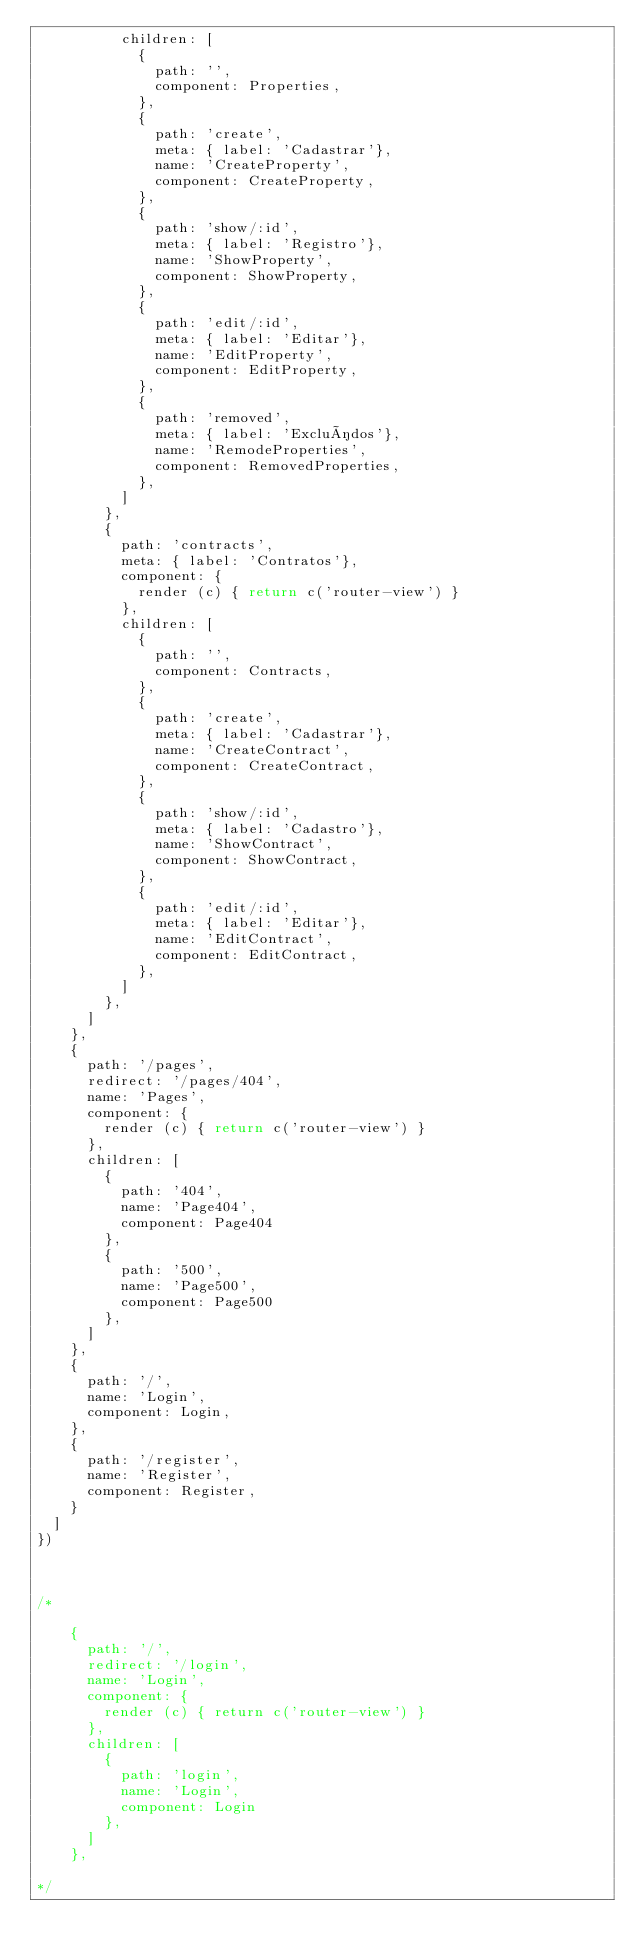Convert code to text. <code><loc_0><loc_0><loc_500><loc_500><_JavaScript_>          children: [
            {
              path: '',
              component: Properties,
            },
            {
              path: 'create',
              meta: { label: 'Cadastrar'},
              name: 'CreateProperty',
              component: CreateProperty,
            },
            {
              path: 'show/:id',
              meta: { label: 'Registro'},
              name: 'ShowProperty',
              component: ShowProperty,
            },
            {
              path: 'edit/:id',
              meta: { label: 'Editar'},
              name: 'EditProperty',
              component: EditProperty,
            },
            {
              path: 'removed',
              meta: { label: 'Excluídos'},
              name: 'RemodeProperties',
              component: RemovedProperties,
            },
          ]
        },
        {
          path: 'contracts',
          meta: { label: 'Contratos'},
          component: {
            render (c) { return c('router-view') }
          },
          children: [
            {
              path: '',
              component: Contracts,
            },
            {
              path: 'create',
              meta: { label: 'Cadastrar'},
              name: 'CreateContract',
              component: CreateContract,
            },
            {
              path: 'show/:id',
              meta: { label: 'Cadastro'},
              name: 'ShowContract',
              component: ShowContract,
            },
            {
              path: 'edit/:id',
              meta: { label: 'Editar'},
              name: 'EditContract',
              component: EditContract,
            },
          ]
        },
      ]
    },
    {
      path: '/pages',
      redirect: '/pages/404',
      name: 'Pages',
      component: {
        render (c) { return c('router-view') }
      },
      children: [
        {
          path: '404',
          name: 'Page404',
          component: Page404
        },
        {
          path: '500',
          name: 'Page500',
          component: Page500
        },
      ]
    },
    {
      path: '/',
      name: 'Login',
      component: Login,
    },
    {
      path: '/register',
      name: 'Register',
      component: Register,
    }
  ]
})



/*

    {
      path: '/',
      redirect: '/login',
      name: 'Login',
      component: {
        render (c) { return c('router-view') }
      },
      children: [
        {
          path: 'login',
          name: 'Login',
          component: Login
        },
      ]
    },

*/
</code> 